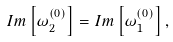Convert formula to latex. <formula><loc_0><loc_0><loc_500><loc_500>I m \left [ \omega _ { 2 } ^ { ( 0 ) } \right ] = I m \left [ \omega _ { 1 } ^ { ( 0 ) } \right ] ,</formula> 